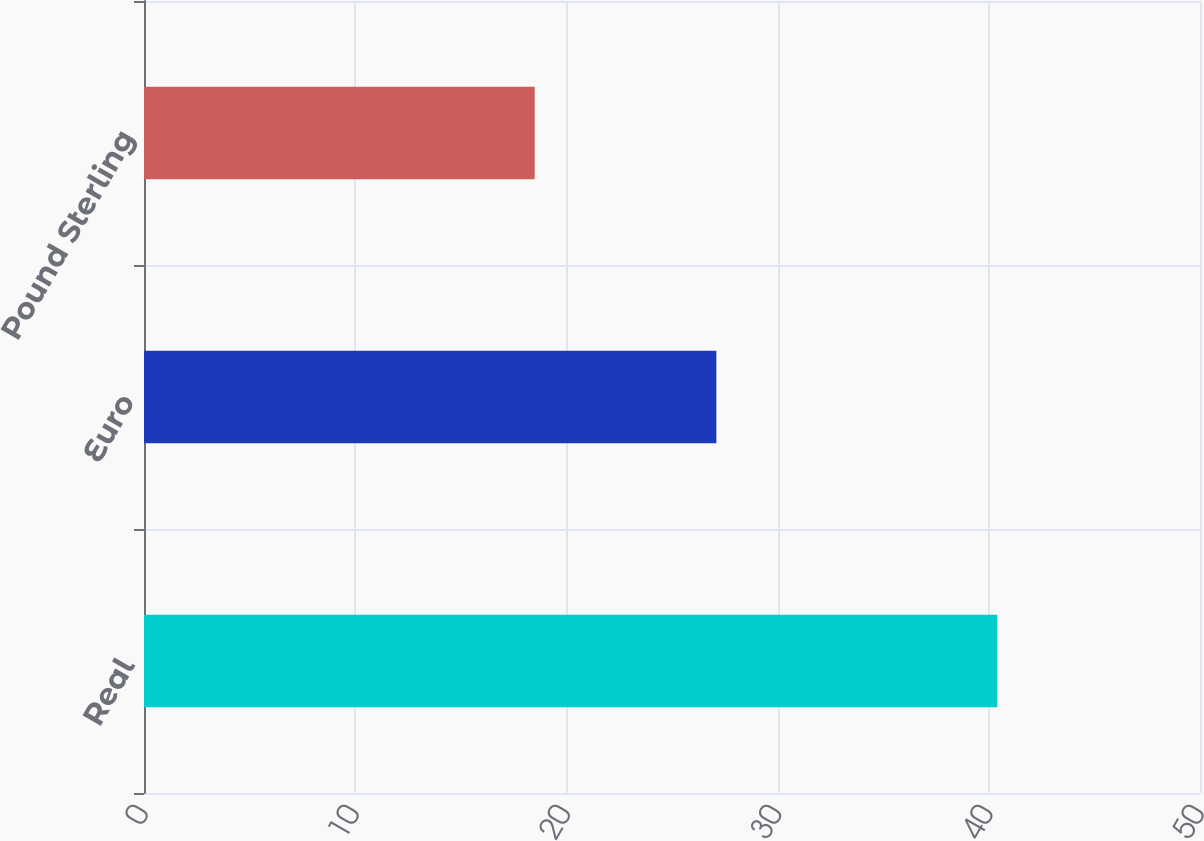Convert chart to OTSL. <chart><loc_0><loc_0><loc_500><loc_500><bar_chart><fcel>Real<fcel>Euro<fcel>Pound Sterling<nl><fcel>40.4<fcel>27.1<fcel>18.5<nl></chart> 